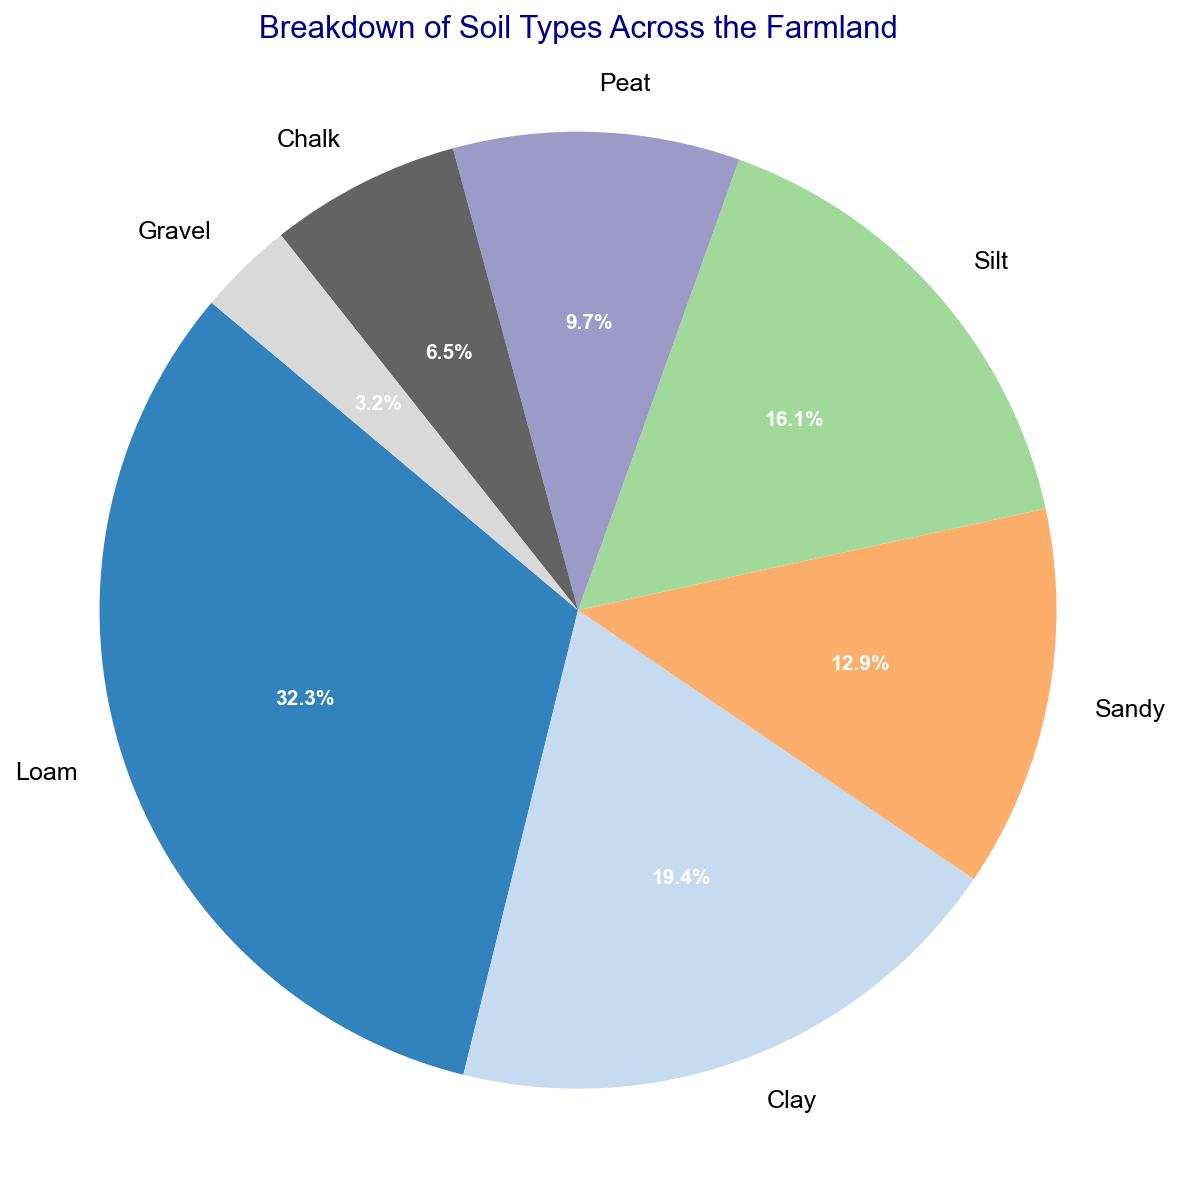What percent of the farmland is occupied by Loam soil? The segment labeled "Loam" shows the percentage directly on the pie chart.
Answer: 29.4% Which soil type covers the smallest area? By observing the pie chart, the smallest segment corresponds to Gravel.
Answer: Gravel How many hectares in total are covered by Clay and Silt? adding the area values for Clay and Silt: 30 + 25 = 55 hectares.
Answer: 55 hectares Is the area covered by Sandy soil greater than that of Peat soil? Comparing the segments corresponding to Sandy and Peat, Sandy covers 20 hectares and Peat covers 15 hectares. Hence, Sandy soil covers more area.
Answer: Yes What fraction of the farmland is covered by Chalk soil types? The segment labeled "Chalk" shows 5.9%, which is equivalent to 5.9/100 = 0.059.
Answer: 0.059 Arrange the soil types in descending order based on the area they cover. By comparing the sizes of the segments visually: Loam > Clay > Silt > Sandy > Peat > Chalk > Gravel.
Answer: Loam, Clay, Silt, Sandy, Peat, Chalk, Gravel How many percentage points differ between Loam soil and the average of Gravel and Chalk soils in area coverage? Calculating average area coverage for Gravel and Chalk: (5.9% + 2.9%) / 2 = 4.4%; difference between Loam (29.4%) and 4.4% is 25 percentage points.
Answer: 25% Which soil types combined cover more area than Loam soil alone? Adding the areas of other soil types and comparing: Clay (30) + Silt (25) + Sandy (20) + Peat (15) + Chalk (10) + Gravel (5) = 105 hectares exceeds Loam's 50 hectares.
Answer: All other combined 